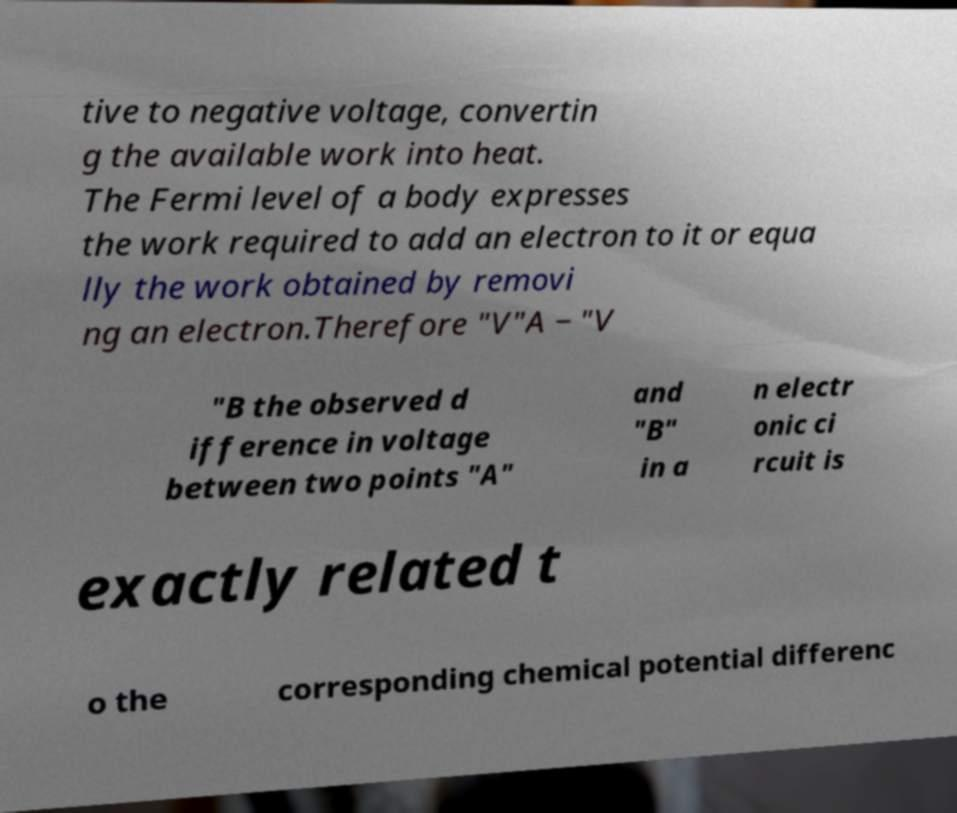What messages or text are displayed in this image? I need them in a readable, typed format. tive to negative voltage, convertin g the available work into heat. The Fermi level of a body expresses the work required to add an electron to it or equa lly the work obtained by removi ng an electron.Therefore "V"A − "V "B the observed d ifference in voltage between two points "A" and "B" in a n electr onic ci rcuit is exactly related t o the corresponding chemical potential differenc 